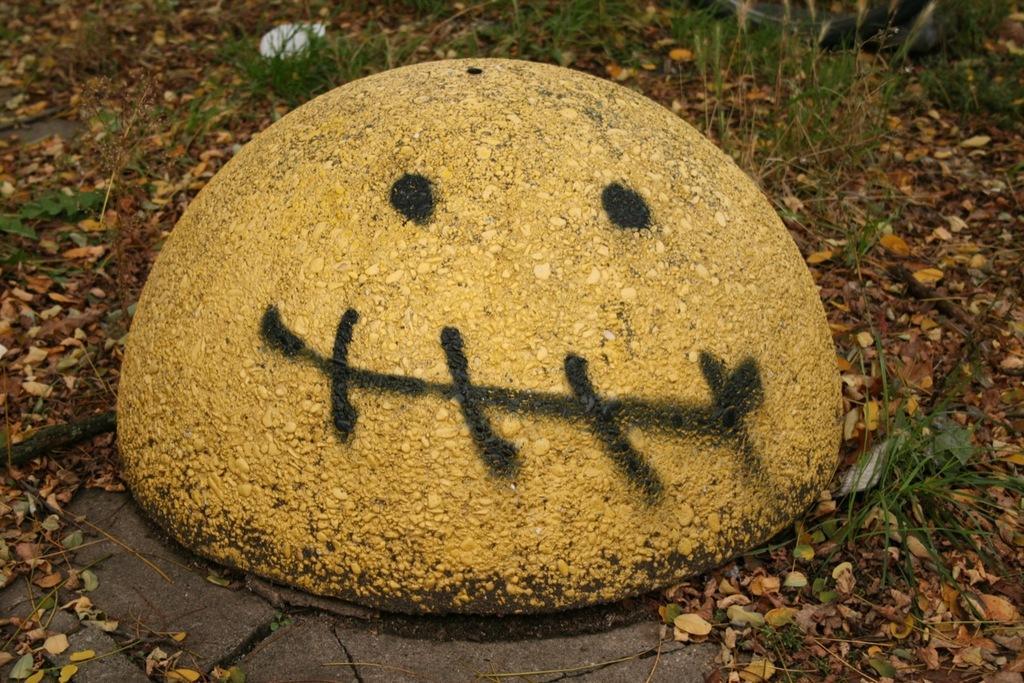In one or two sentences, can you explain what this image depicts? In this image I can see the ground, few leaves on the ground and some grass which is green in color. I can see a yellow colored object and something is painted on it with black color. 